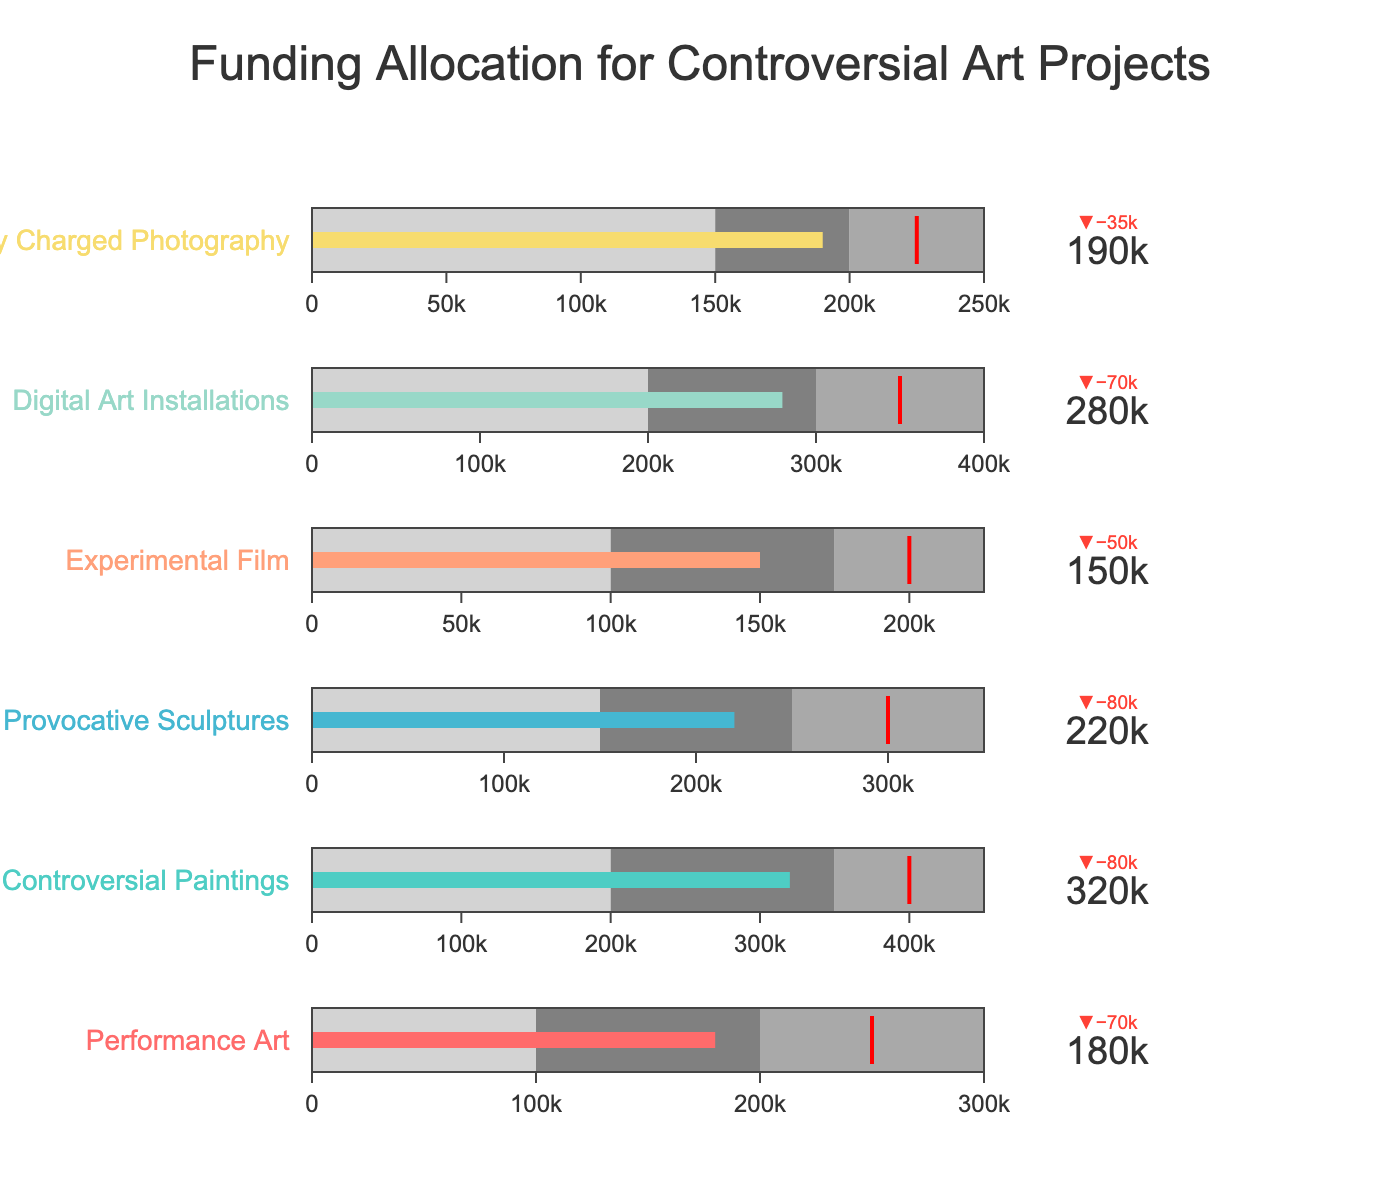Which category has the highest actual funding amount? By examining the bullet chart, "Controversial Paintings" has a higher value bar than other categories in the actual funding amount.
Answer: Controversial Paintings What is the target funding amount for Digital Art Installations? The bullet chart indicates a red threshold line at the target value. For "Digital Art Installations," this line points to the target funding amount.
Answer: 350,000 Which category is furthest from meeting its target funding amount? Comparison of the delta values shows the distance from each category's actual value to its target. "Performance Art" has the largest difference between actual (180,000) and target (250,000).
Answer: Performance Art Are there any categories where the actual funding amount exceeds the target funding amount? By looking at the delta indicators, no categories have their actual funding amount exceeding their target, as all actual values lie before their respective red threshold lines.
Answer: No What is the actual funding amount for Politically Charged Photography? The actual funding amount is indicated on the value bar. For "Politically Charged Photography," the value next to the bar provides this information.
Answer: 190,000 How much more funding is needed for Provocative Sculptures to meet the target? The target funding for "Provocative Sculptures" is 300,000, and the actual is 220,000. The difference between these values indicates the needed amount. 300,000 - 220,000 = 80,000.
Answer: 80,000 Which category is closest to its target funding amount? By examining the difference between actual and target values, "Politically Charged Photography," with a smaller delta, shows the least difference between its actual (190,000) and target (225,000).
Answer: Politically Charged Photography Are there any categories with actual funding amounts within their good performance range (Range3)? Checking the ranges, no categories' actual values fall into their top performance range (the third gray range).
Answer: No How does the actual funding of Experimental Film compare to its target? The actual funding for "Experimental Film" is compared to its target. The actual (150,000) is less than the target (200,000), indicating it falls short by the delta amount.
Answer: Less Which category has the most significant difference between Range1 and Range3? Calculating the difference between Range1 and Range3 for each category shows "Controversial Paintings" has the largest range difference: 450,000 - 200,000 = 250,000.
Answer: Controversial Paintings 